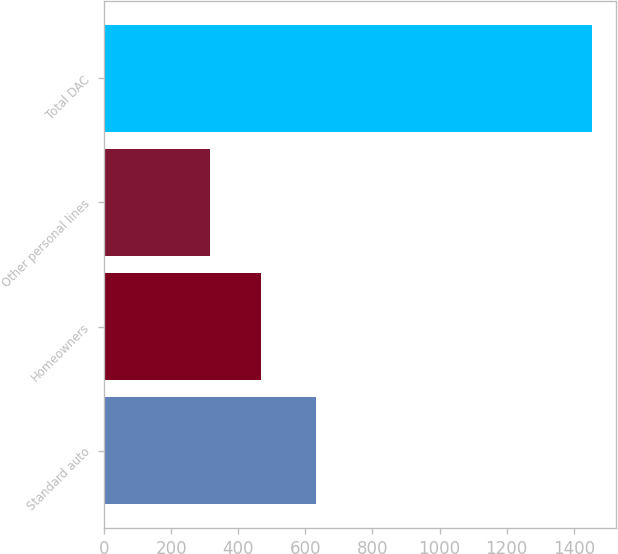Convert chart to OTSL. <chart><loc_0><loc_0><loc_500><loc_500><bar_chart><fcel>Standard auto<fcel>Homeowners<fcel>Other personal lines<fcel>Total DAC<nl><fcel>631<fcel>469<fcel>316<fcel>1453<nl></chart> 